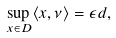<formula> <loc_0><loc_0><loc_500><loc_500>\sup _ { x \in D } \langle x , \nu \rangle = \epsilon d ,</formula> 